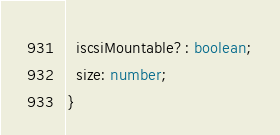Convert code to text. <code><loc_0><loc_0><loc_500><loc_500><_TypeScript_>  iscsiMountable?: boolean;
  size: number;
}
</code> 